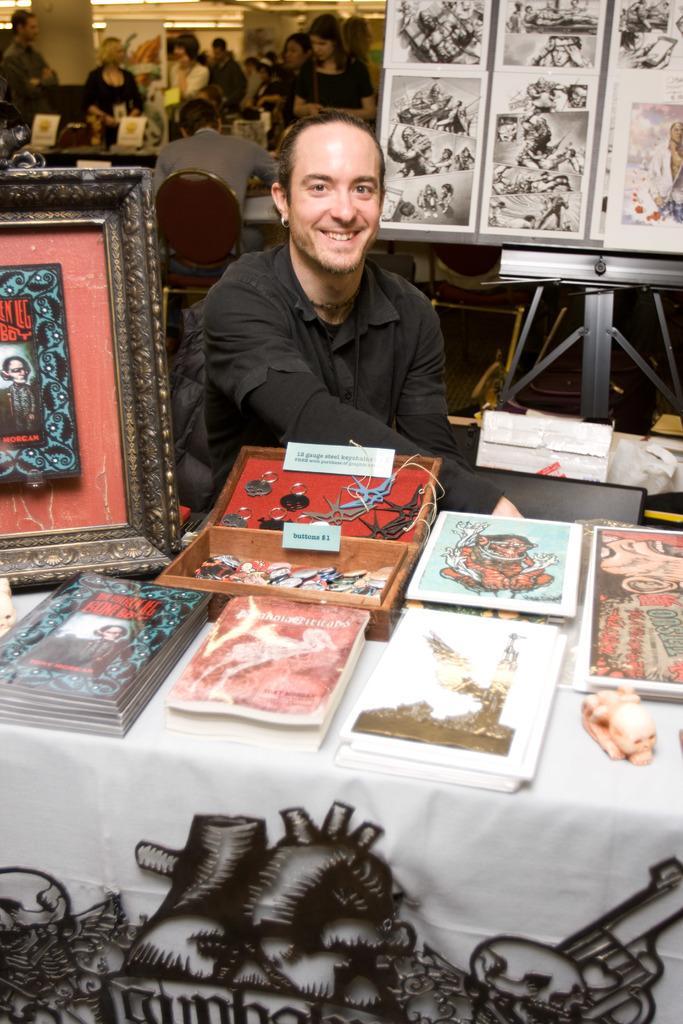Could you give a brief overview of what you see in this image? In the image there is a man wearing a black color dress sitting on chair in front of a table. On table we can see box,books,photo frames and background there are group of people who are standing and we can also see a hoarding on right side, on top there is a roof which is in white color. 